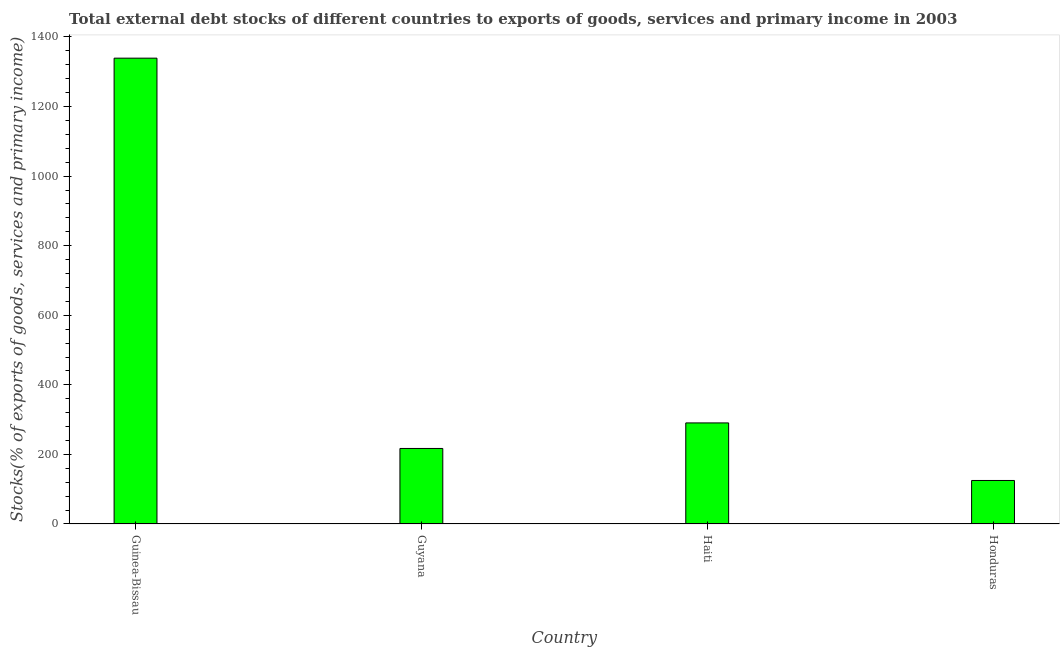What is the title of the graph?
Provide a short and direct response. Total external debt stocks of different countries to exports of goods, services and primary income in 2003. What is the label or title of the Y-axis?
Keep it short and to the point. Stocks(% of exports of goods, services and primary income). What is the external debt stocks in Guinea-Bissau?
Give a very brief answer. 1339.05. Across all countries, what is the maximum external debt stocks?
Your response must be concise. 1339.05. Across all countries, what is the minimum external debt stocks?
Your response must be concise. 125.05. In which country was the external debt stocks maximum?
Keep it short and to the point. Guinea-Bissau. In which country was the external debt stocks minimum?
Ensure brevity in your answer.  Honduras. What is the sum of the external debt stocks?
Provide a succinct answer. 1971.68. What is the difference between the external debt stocks in Guinea-Bissau and Honduras?
Your response must be concise. 1214.01. What is the average external debt stocks per country?
Keep it short and to the point. 492.92. What is the median external debt stocks?
Keep it short and to the point. 253.79. In how many countries, is the external debt stocks greater than 160 %?
Your answer should be compact. 3. What is the ratio of the external debt stocks in Guyana to that in Haiti?
Your answer should be compact. 0.75. Is the difference between the external debt stocks in Haiti and Honduras greater than the difference between any two countries?
Your answer should be compact. No. What is the difference between the highest and the second highest external debt stocks?
Make the answer very short. 1048.55. Is the sum of the external debt stocks in Guyana and Haiti greater than the maximum external debt stocks across all countries?
Provide a short and direct response. No. What is the difference between the highest and the lowest external debt stocks?
Make the answer very short. 1214.01. In how many countries, is the external debt stocks greater than the average external debt stocks taken over all countries?
Your answer should be very brief. 1. How many bars are there?
Provide a succinct answer. 4. Are all the bars in the graph horizontal?
Offer a terse response. No. What is the difference between two consecutive major ticks on the Y-axis?
Your response must be concise. 200. What is the Stocks(% of exports of goods, services and primary income) of Guinea-Bissau?
Your response must be concise. 1339.05. What is the Stocks(% of exports of goods, services and primary income) in Guyana?
Make the answer very short. 217.07. What is the Stocks(% of exports of goods, services and primary income) of Haiti?
Offer a very short reply. 290.51. What is the Stocks(% of exports of goods, services and primary income) in Honduras?
Ensure brevity in your answer.  125.05. What is the difference between the Stocks(% of exports of goods, services and primary income) in Guinea-Bissau and Guyana?
Provide a short and direct response. 1121.99. What is the difference between the Stocks(% of exports of goods, services and primary income) in Guinea-Bissau and Haiti?
Provide a succinct answer. 1048.55. What is the difference between the Stocks(% of exports of goods, services and primary income) in Guinea-Bissau and Honduras?
Keep it short and to the point. 1214.01. What is the difference between the Stocks(% of exports of goods, services and primary income) in Guyana and Haiti?
Your response must be concise. -73.44. What is the difference between the Stocks(% of exports of goods, services and primary income) in Guyana and Honduras?
Your answer should be compact. 92.02. What is the difference between the Stocks(% of exports of goods, services and primary income) in Haiti and Honduras?
Ensure brevity in your answer.  165.46. What is the ratio of the Stocks(% of exports of goods, services and primary income) in Guinea-Bissau to that in Guyana?
Your answer should be compact. 6.17. What is the ratio of the Stocks(% of exports of goods, services and primary income) in Guinea-Bissau to that in Haiti?
Offer a terse response. 4.61. What is the ratio of the Stocks(% of exports of goods, services and primary income) in Guinea-Bissau to that in Honduras?
Give a very brief answer. 10.71. What is the ratio of the Stocks(% of exports of goods, services and primary income) in Guyana to that in Haiti?
Keep it short and to the point. 0.75. What is the ratio of the Stocks(% of exports of goods, services and primary income) in Guyana to that in Honduras?
Give a very brief answer. 1.74. What is the ratio of the Stocks(% of exports of goods, services and primary income) in Haiti to that in Honduras?
Offer a very short reply. 2.32. 